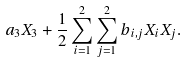Convert formula to latex. <formula><loc_0><loc_0><loc_500><loc_500>a _ { 3 } X _ { 3 } + \frac { 1 } { 2 } \sum _ { i = 1 } ^ { 2 } \sum _ { j = 1 } ^ { 2 } b _ { i , j } X _ { i } X _ { j } .</formula> 